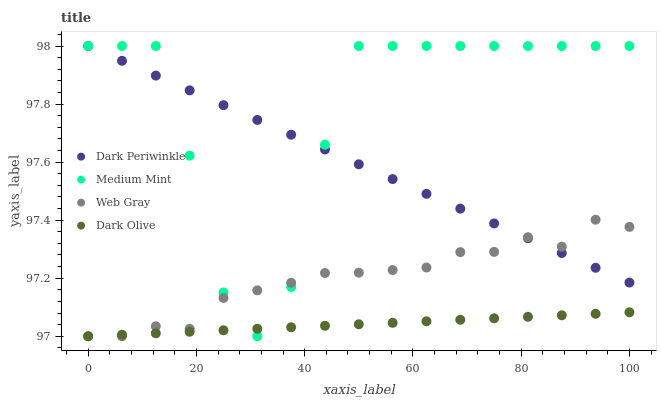Does Dark Olive have the minimum area under the curve?
Answer yes or no. Yes. Does Medium Mint have the maximum area under the curve?
Answer yes or no. Yes. Does Web Gray have the minimum area under the curve?
Answer yes or no. No. Does Web Gray have the maximum area under the curve?
Answer yes or no. No. Is Dark Olive the smoothest?
Answer yes or no. Yes. Is Medium Mint the roughest?
Answer yes or no. Yes. Is Web Gray the smoothest?
Answer yes or no. No. Is Web Gray the roughest?
Answer yes or no. No. Does Web Gray have the lowest value?
Answer yes or no. Yes. Does Dark Periwinkle have the lowest value?
Answer yes or no. No. Does Dark Periwinkle have the highest value?
Answer yes or no. Yes. Does Web Gray have the highest value?
Answer yes or no. No. Is Dark Olive less than Dark Periwinkle?
Answer yes or no. Yes. Is Dark Periwinkle greater than Dark Olive?
Answer yes or no. Yes. Does Dark Periwinkle intersect Web Gray?
Answer yes or no. Yes. Is Dark Periwinkle less than Web Gray?
Answer yes or no. No. Is Dark Periwinkle greater than Web Gray?
Answer yes or no. No. Does Dark Olive intersect Dark Periwinkle?
Answer yes or no. No. 